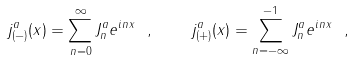Convert formula to latex. <formula><loc_0><loc_0><loc_500><loc_500>j ^ { a } _ { ( - ) } ( x ) = \sum ^ { \infty } _ { n = 0 } J ^ { a } _ { n } e ^ { i n x } \ , \quad j ^ { a } _ { ( + ) } ( x ) = \sum ^ { - 1 } _ { n = - \infty } J ^ { a } _ { n } e ^ { i n x } \ ,</formula> 